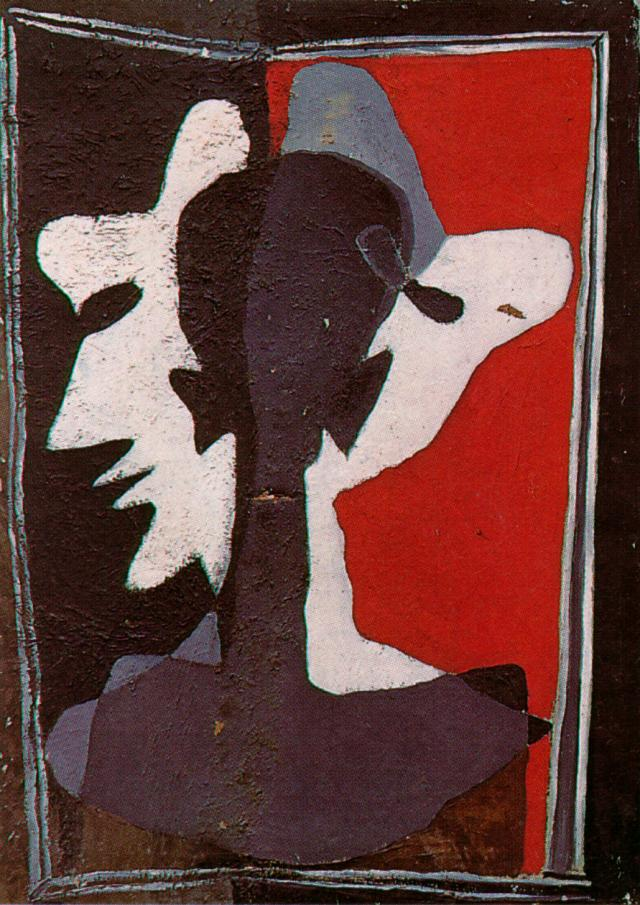What kind of story could be inspired by the elements present in the artwork? In a distant future, in a realm dominated by abstract expressionism, lived an artist named Livia. She had the unique ability to bring her paintings to life. Every stroke and layer she added to her canvas could transform into a real entity. Her most recent creation, which featured a dynamic interplay of red, black, and white faces, held incredible power. As she painted, these faces began to communicate with each other and the outside world. They discussed past conflicts, reconciled their differences, and planned their futures. However, their existence in the vivid red background of Livia’s world proved both a blessing and a curse, as they struggled to adapt to the complexities of her emotions portrayed in the art. The story explores themes of creation, self-expression, and the sentience of art. 